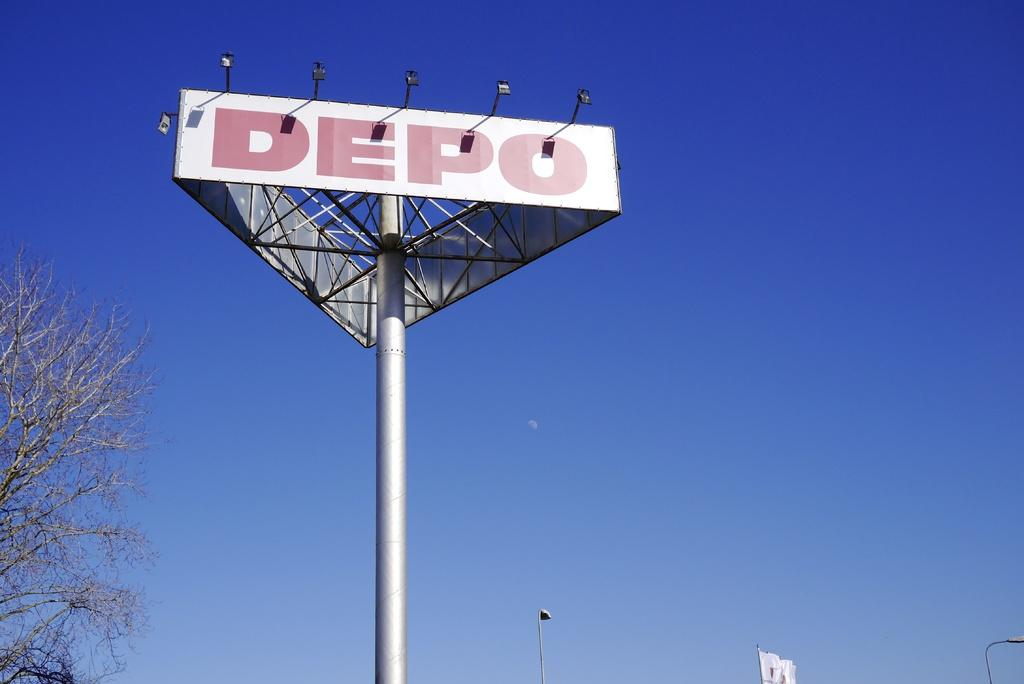Provide a one-sentence caption for the provided image. A large lighted sign for DEPO against the backdrop of a blue sky. 